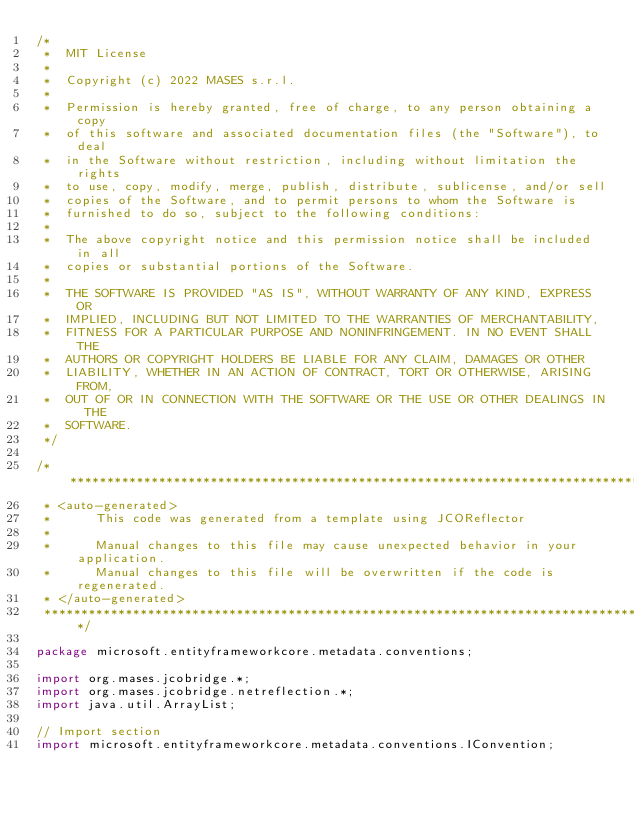Convert code to text. <code><loc_0><loc_0><loc_500><loc_500><_Java_>/*
 *  MIT License
 *
 *  Copyright (c) 2022 MASES s.r.l.
 *
 *  Permission is hereby granted, free of charge, to any person obtaining a copy
 *  of this software and associated documentation files (the "Software"), to deal
 *  in the Software without restriction, including without limitation the rights
 *  to use, copy, modify, merge, publish, distribute, sublicense, and/or sell
 *  copies of the Software, and to permit persons to whom the Software is
 *  furnished to do so, subject to the following conditions:
 *
 *  The above copyright notice and this permission notice shall be included in all
 *  copies or substantial portions of the Software.
 *
 *  THE SOFTWARE IS PROVIDED "AS IS", WITHOUT WARRANTY OF ANY KIND, EXPRESS OR
 *  IMPLIED, INCLUDING BUT NOT LIMITED TO THE WARRANTIES OF MERCHANTABILITY,
 *  FITNESS FOR A PARTICULAR PURPOSE AND NONINFRINGEMENT. IN NO EVENT SHALL THE
 *  AUTHORS OR COPYRIGHT HOLDERS BE LIABLE FOR ANY CLAIM, DAMAGES OR OTHER
 *  LIABILITY, WHETHER IN AN ACTION OF CONTRACT, TORT OR OTHERWISE, ARISING FROM,
 *  OUT OF OR IN CONNECTION WITH THE SOFTWARE OR THE USE OR OTHER DEALINGS IN THE
 *  SOFTWARE.
 */

/**************************************************************************************
 * <auto-generated>
 *      This code was generated from a template using JCOReflector
 * 
 *      Manual changes to this file may cause unexpected behavior in your application.
 *      Manual changes to this file will be overwritten if the code is regenerated.
 * </auto-generated>
 *************************************************************************************/

package microsoft.entityframeworkcore.metadata.conventions;

import org.mases.jcobridge.*;
import org.mases.jcobridge.netreflection.*;
import java.util.ArrayList;

// Import section
import microsoft.entityframeworkcore.metadata.conventions.IConvention;</code> 